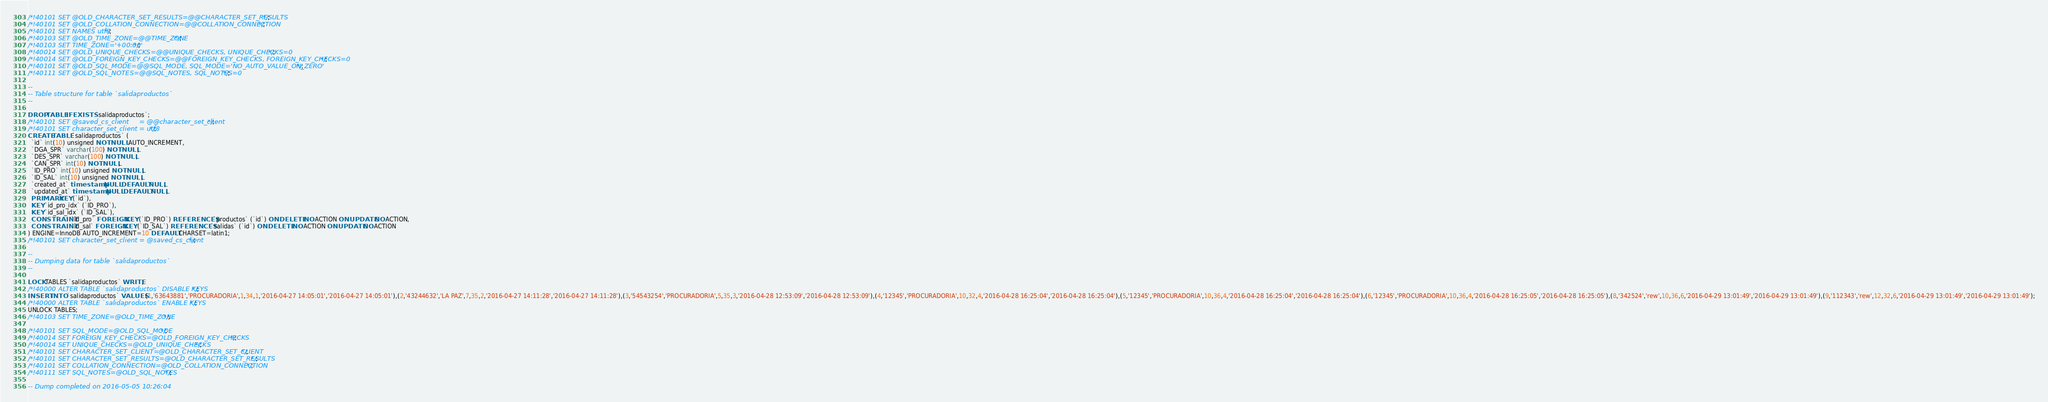<code> <loc_0><loc_0><loc_500><loc_500><_SQL_>/*!40101 SET @OLD_CHARACTER_SET_RESULTS=@@CHARACTER_SET_RESULTS */;
/*!40101 SET @OLD_COLLATION_CONNECTION=@@COLLATION_CONNECTION */;
/*!40101 SET NAMES utf8 */;
/*!40103 SET @OLD_TIME_ZONE=@@TIME_ZONE */;
/*!40103 SET TIME_ZONE='+00:00' */;
/*!40014 SET @OLD_UNIQUE_CHECKS=@@UNIQUE_CHECKS, UNIQUE_CHECKS=0 */;
/*!40014 SET @OLD_FOREIGN_KEY_CHECKS=@@FOREIGN_KEY_CHECKS, FOREIGN_KEY_CHECKS=0 */;
/*!40101 SET @OLD_SQL_MODE=@@SQL_MODE, SQL_MODE='NO_AUTO_VALUE_ON_ZERO' */;
/*!40111 SET @OLD_SQL_NOTES=@@SQL_NOTES, SQL_NOTES=0 */;

--
-- Table structure for table `salidaproductos`
--

DROP TABLE IF EXISTS `salidaproductos`;
/*!40101 SET @saved_cs_client     = @@character_set_client */;
/*!40101 SET character_set_client = utf8 */;
CREATE TABLE `salidaproductos` (
  `id` int(10) unsigned NOT NULL AUTO_INCREMENT,
  `DGA_SPR` varchar(100) NOT NULL,
  `DES_SPR` varchar(100) NOT NULL,
  `CAN_SPR` int(10) NOT NULL,
  `ID_PRO` int(10) unsigned NOT NULL,
  `ID_SAL` int(10) unsigned NOT NULL,
  `created_at` timestamp NULL DEFAULT NULL,
  `updated_at` timestamp NULL DEFAULT NULL,
  PRIMARY KEY (`id`),
  KEY `id_pro_idx` (`ID_PRO`),
  KEY `id_sal_idx` (`ID_SAL`),
  CONSTRAINT `id_pro` FOREIGN KEY (`ID_PRO`) REFERENCES `productos` (`id`) ON DELETE NO ACTION ON UPDATE NO ACTION,
  CONSTRAINT `id_sal` FOREIGN KEY (`ID_SAL`) REFERENCES `salidas` (`id`) ON DELETE NO ACTION ON UPDATE NO ACTION
) ENGINE=InnoDB AUTO_INCREMENT=10 DEFAULT CHARSET=latin1;
/*!40101 SET character_set_client = @saved_cs_client */;

--
-- Dumping data for table `salidaproductos`
--

LOCK TABLES `salidaproductos` WRITE;
/*!40000 ALTER TABLE `salidaproductos` DISABLE KEYS */;
INSERT INTO `salidaproductos` VALUES (1,'63643881','PROCURADORIA',1,34,1,'2016-04-27 14:05:01','2016-04-27 14:05:01'),(2,'43244632','LA PAZ',7,35,2,'2016-04-27 14:11:28','2016-04-27 14:11:28'),(3,'54543254','PROCURADORIA',5,35,3,'2016-04-28 12:53:09','2016-04-28 12:53:09'),(4,'12345','PROCURADORIA',10,32,4,'2016-04-28 16:25:04','2016-04-28 16:25:04'),(5,'12345','PROCURADORIA',10,36,4,'2016-04-28 16:25:04','2016-04-28 16:25:04'),(6,'12345','PROCURADORIA',10,36,4,'2016-04-28 16:25:05','2016-04-28 16:25:05'),(8,'342524','rew',10,36,6,'2016-04-29 13:01:49','2016-04-29 13:01:49'),(9,'112343','rew',12,32,6,'2016-04-29 13:01:49','2016-04-29 13:01:49');
/*!40000 ALTER TABLE `salidaproductos` ENABLE KEYS */;
UNLOCK TABLES;
/*!40103 SET TIME_ZONE=@OLD_TIME_ZONE */;

/*!40101 SET SQL_MODE=@OLD_SQL_MODE */;
/*!40014 SET FOREIGN_KEY_CHECKS=@OLD_FOREIGN_KEY_CHECKS */;
/*!40014 SET UNIQUE_CHECKS=@OLD_UNIQUE_CHECKS */;
/*!40101 SET CHARACTER_SET_CLIENT=@OLD_CHARACTER_SET_CLIENT */;
/*!40101 SET CHARACTER_SET_RESULTS=@OLD_CHARACTER_SET_RESULTS */;
/*!40101 SET COLLATION_CONNECTION=@OLD_COLLATION_CONNECTION */;
/*!40111 SET SQL_NOTES=@OLD_SQL_NOTES */;

-- Dump completed on 2016-05-05 10:26:04
</code> 